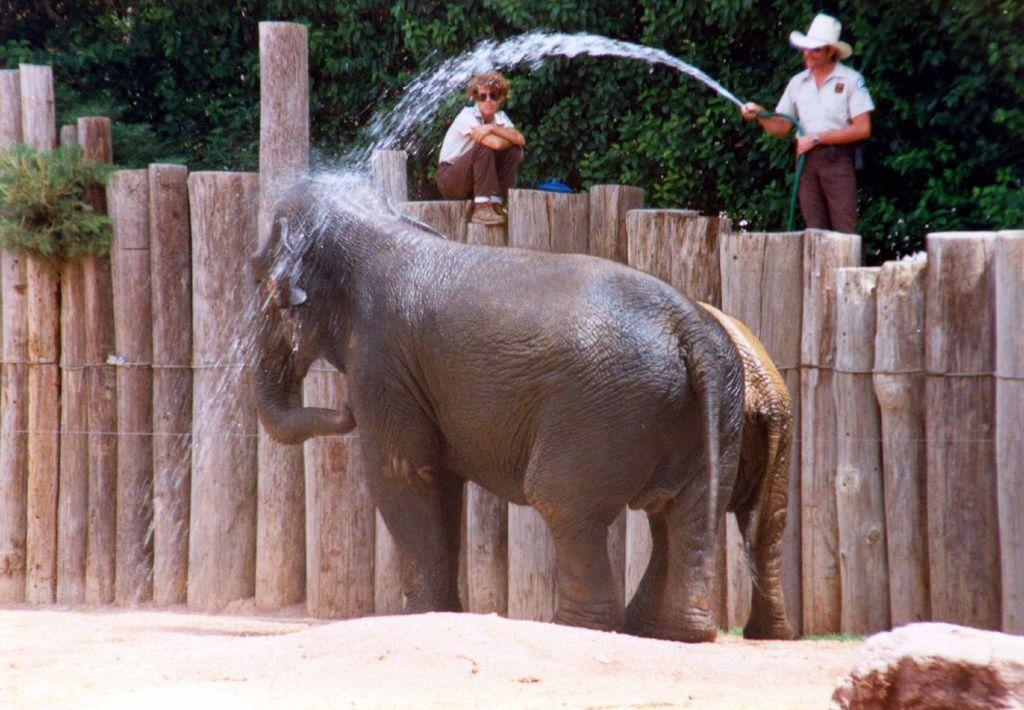Can you describe this image briefly? In this image two elephants are standing on the land. A person wearing goggles is sitting on the wooden trunks. A person is standing behind the wooden trunks. He is holding a pipe and throwing the water on the elephants. He is wearing a hat. Behind him there are few trees. Right bottom there is a rock on the land. 